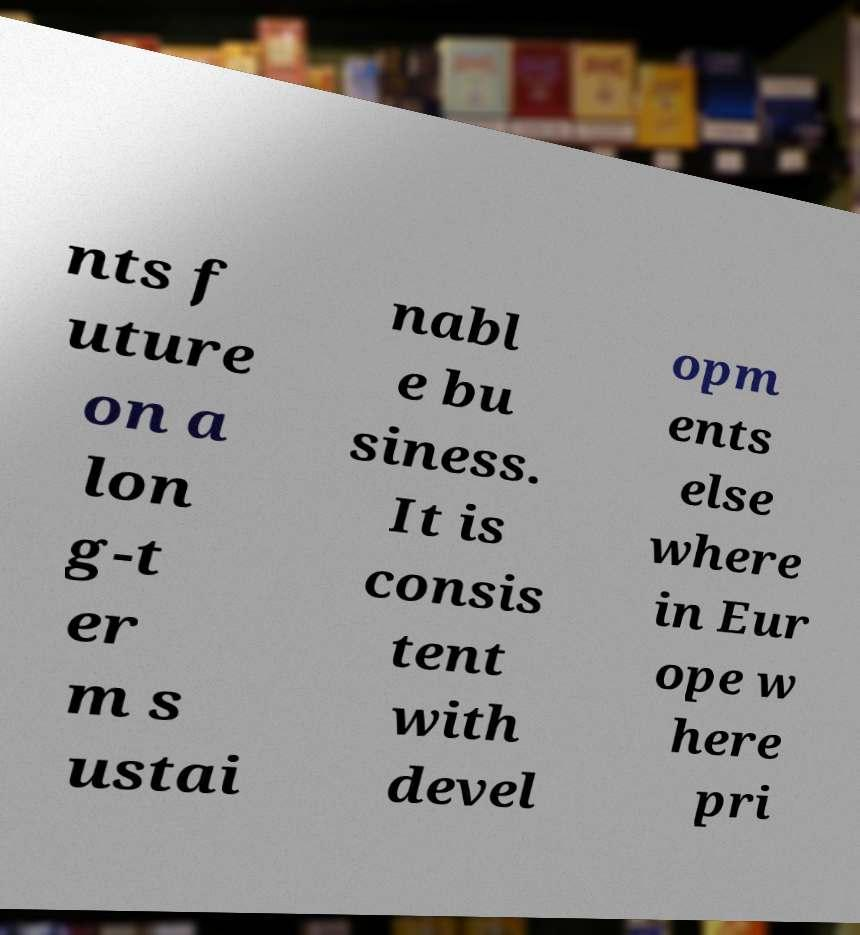I need the written content from this picture converted into text. Can you do that? nts f uture on a lon g-t er m s ustai nabl e bu siness. It is consis tent with devel opm ents else where in Eur ope w here pri 